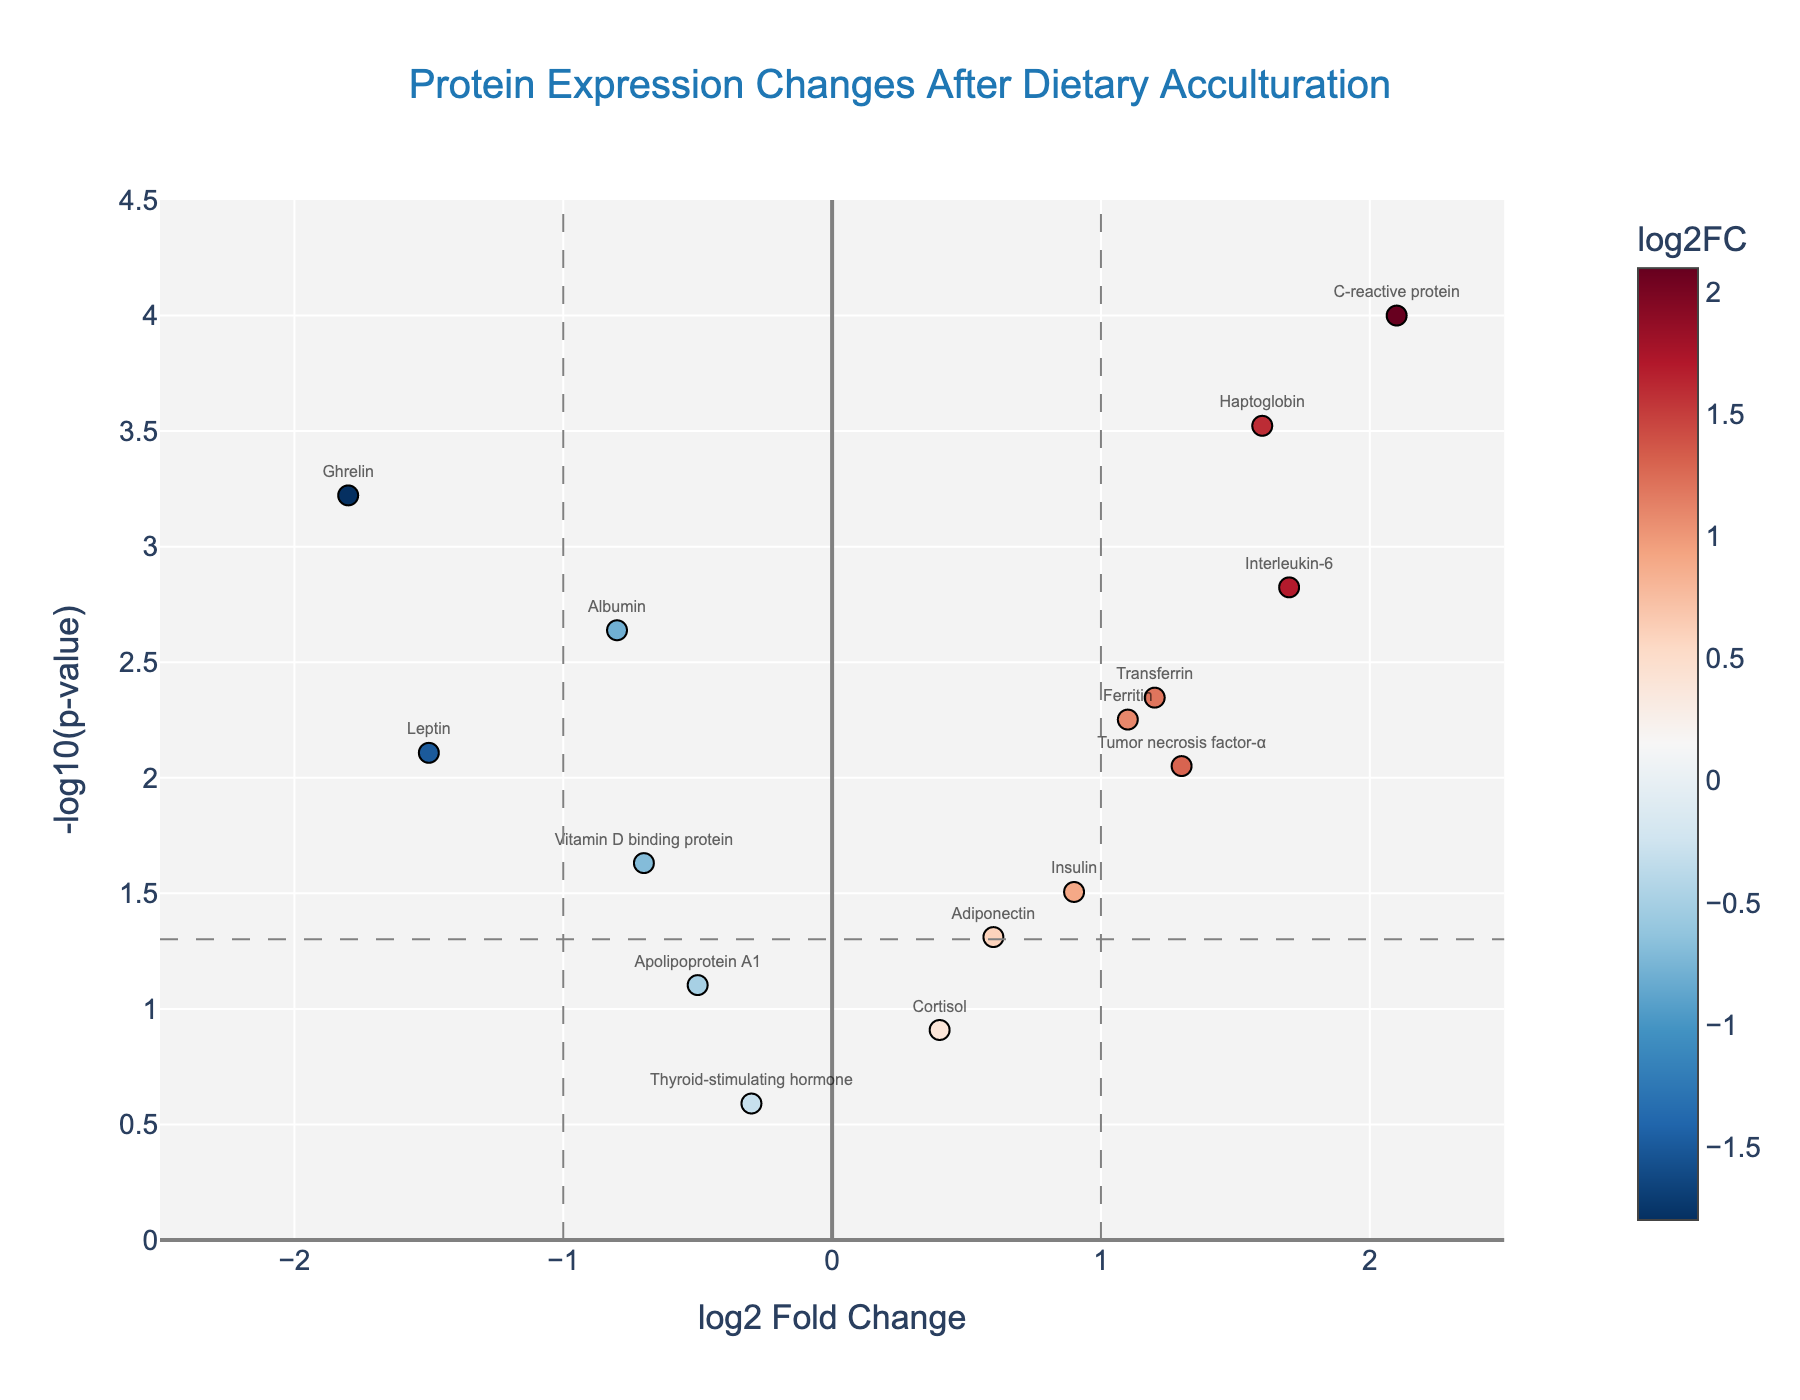what is the title of the plot? The title of the plot can be found at the top center of the figure, with large font size and often a descriptor for the data visualization.
Answer: "Protein Expression Changes After Dietary Acculturation" which protein has the highest log2 fold change? Locate the data point furthest to the right on the x-axis. The hover text or label associated with this point should describe the protein.
Answer: C-reactive protein what is the significance threshold for p-values in the plot? Identify the horizontal line on the plot; it represents the p-value threshold line. Read the corresponding y-axis value for this line.
Answer: 0.05 how many proteins have a p-value less than 0.05? Count the number of points above the horizontal line that represents the significance threshold (-log10(p-value) around 1.3).
Answer: 11 which protein shows the greatest increase in expression? Look for the protein with the highest positive log2 fold change and cross-reference with the point furthest to the right above the threshold line on the plot.
Answer: C-reactive protein compare the expressions of leptin and ghrelin. Which one has a larger log2 fold change? Identify the data points for leptin and ghrelin by looking at the labels or hover text. Compare their log2 fold change values.
Answer: Ghrelin what color represents the lowest log2 fold change in the plot? Identify the color coding for the data points. The lowest log2 fold change points will be at the far left and indicated with the corresponding color.
Answer: Blue do any proteins show both a log2 fold change less than -1 and a p-value less than 0.05? Identify data points in the top-left quadrant where log2FC < -1 and they fall above the threshold line for p-value significance (-log10(p) > 1.3).
Answer: Leptin and Ghrelin which protein has the smallest p-value in the plot? Find the highest y-coordinate (-log10(p-value)) on the plot. Check the label or hover text of that data point.
Answer: C-reactive protein how does the expression of albumin change after dietary acculturation? Locate the point labeled "Albumin" in the plot. Look at its log2 fold change value on the x-axis.
Answer: Decreases (-0.8) 